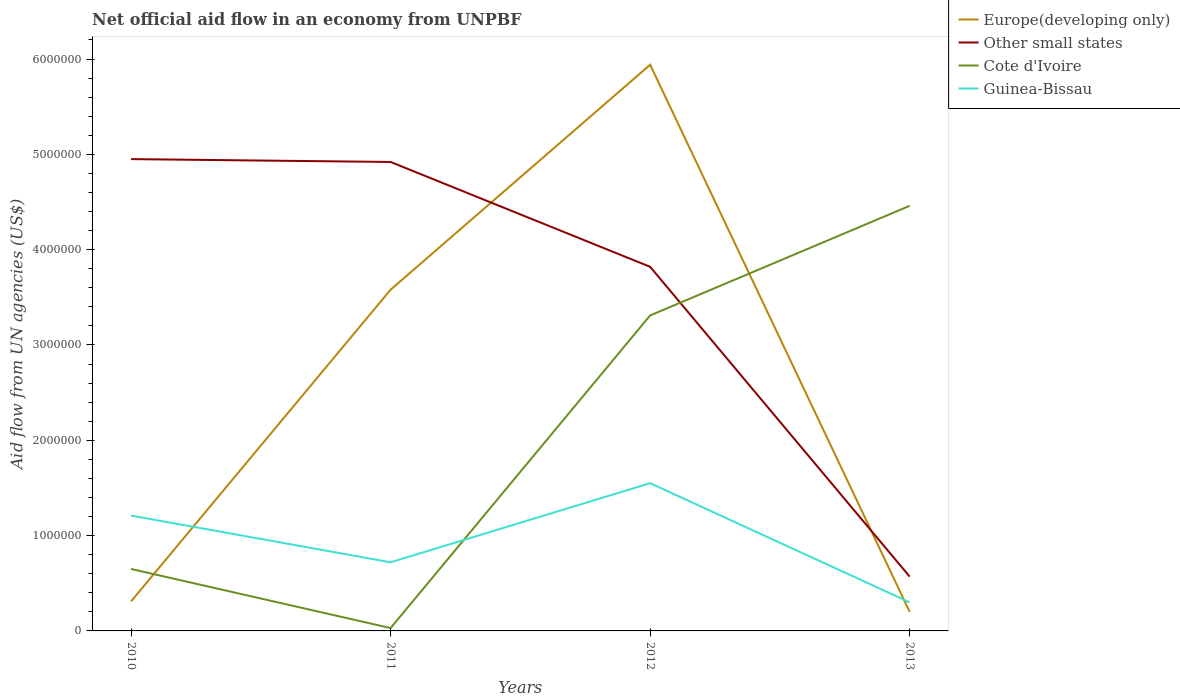How many different coloured lines are there?
Make the answer very short. 4. Is the number of lines equal to the number of legend labels?
Make the answer very short. Yes. Across all years, what is the maximum net official aid flow in Europe(developing only)?
Keep it short and to the point. 2.00e+05. In which year was the net official aid flow in Europe(developing only) maximum?
Keep it short and to the point. 2013. What is the total net official aid flow in Europe(developing only) in the graph?
Make the answer very short. -5.63e+06. What is the difference between the highest and the second highest net official aid flow in Cote d'Ivoire?
Give a very brief answer. 4.43e+06. How many years are there in the graph?
Your answer should be very brief. 4. Are the values on the major ticks of Y-axis written in scientific E-notation?
Your answer should be very brief. No. Where does the legend appear in the graph?
Your answer should be compact. Top right. What is the title of the graph?
Ensure brevity in your answer.  Net official aid flow in an economy from UNPBF. Does "Hungary" appear as one of the legend labels in the graph?
Give a very brief answer. No. What is the label or title of the Y-axis?
Offer a terse response. Aid flow from UN agencies (US$). What is the Aid flow from UN agencies (US$) of Europe(developing only) in 2010?
Your answer should be very brief. 3.10e+05. What is the Aid flow from UN agencies (US$) in Other small states in 2010?
Ensure brevity in your answer.  4.95e+06. What is the Aid flow from UN agencies (US$) of Cote d'Ivoire in 2010?
Make the answer very short. 6.50e+05. What is the Aid flow from UN agencies (US$) in Guinea-Bissau in 2010?
Offer a terse response. 1.21e+06. What is the Aid flow from UN agencies (US$) in Europe(developing only) in 2011?
Keep it short and to the point. 3.58e+06. What is the Aid flow from UN agencies (US$) of Other small states in 2011?
Provide a short and direct response. 4.92e+06. What is the Aid flow from UN agencies (US$) of Cote d'Ivoire in 2011?
Offer a very short reply. 3.00e+04. What is the Aid flow from UN agencies (US$) of Guinea-Bissau in 2011?
Keep it short and to the point. 7.20e+05. What is the Aid flow from UN agencies (US$) in Europe(developing only) in 2012?
Your response must be concise. 5.94e+06. What is the Aid flow from UN agencies (US$) of Other small states in 2012?
Ensure brevity in your answer.  3.82e+06. What is the Aid flow from UN agencies (US$) of Cote d'Ivoire in 2012?
Provide a short and direct response. 3.31e+06. What is the Aid flow from UN agencies (US$) of Guinea-Bissau in 2012?
Your answer should be compact. 1.55e+06. What is the Aid flow from UN agencies (US$) of Other small states in 2013?
Ensure brevity in your answer.  5.70e+05. What is the Aid flow from UN agencies (US$) of Cote d'Ivoire in 2013?
Your answer should be compact. 4.46e+06. Across all years, what is the maximum Aid flow from UN agencies (US$) in Europe(developing only)?
Offer a very short reply. 5.94e+06. Across all years, what is the maximum Aid flow from UN agencies (US$) of Other small states?
Offer a very short reply. 4.95e+06. Across all years, what is the maximum Aid flow from UN agencies (US$) of Cote d'Ivoire?
Ensure brevity in your answer.  4.46e+06. Across all years, what is the maximum Aid flow from UN agencies (US$) in Guinea-Bissau?
Ensure brevity in your answer.  1.55e+06. Across all years, what is the minimum Aid flow from UN agencies (US$) of Other small states?
Offer a terse response. 5.70e+05. Across all years, what is the minimum Aid flow from UN agencies (US$) in Cote d'Ivoire?
Provide a short and direct response. 3.00e+04. Across all years, what is the minimum Aid flow from UN agencies (US$) in Guinea-Bissau?
Provide a short and direct response. 3.00e+05. What is the total Aid flow from UN agencies (US$) in Europe(developing only) in the graph?
Offer a terse response. 1.00e+07. What is the total Aid flow from UN agencies (US$) in Other small states in the graph?
Give a very brief answer. 1.43e+07. What is the total Aid flow from UN agencies (US$) in Cote d'Ivoire in the graph?
Ensure brevity in your answer.  8.45e+06. What is the total Aid flow from UN agencies (US$) in Guinea-Bissau in the graph?
Offer a terse response. 3.78e+06. What is the difference between the Aid flow from UN agencies (US$) of Europe(developing only) in 2010 and that in 2011?
Give a very brief answer. -3.27e+06. What is the difference between the Aid flow from UN agencies (US$) of Other small states in 2010 and that in 2011?
Your answer should be compact. 3.00e+04. What is the difference between the Aid flow from UN agencies (US$) of Cote d'Ivoire in 2010 and that in 2011?
Offer a very short reply. 6.20e+05. What is the difference between the Aid flow from UN agencies (US$) of Europe(developing only) in 2010 and that in 2012?
Make the answer very short. -5.63e+06. What is the difference between the Aid flow from UN agencies (US$) of Other small states in 2010 and that in 2012?
Provide a succinct answer. 1.13e+06. What is the difference between the Aid flow from UN agencies (US$) of Cote d'Ivoire in 2010 and that in 2012?
Offer a terse response. -2.66e+06. What is the difference between the Aid flow from UN agencies (US$) of Europe(developing only) in 2010 and that in 2013?
Offer a terse response. 1.10e+05. What is the difference between the Aid flow from UN agencies (US$) of Other small states in 2010 and that in 2013?
Provide a short and direct response. 4.38e+06. What is the difference between the Aid flow from UN agencies (US$) of Cote d'Ivoire in 2010 and that in 2013?
Your response must be concise. -3.81e+06. What is the difference between the Aid flow from UN agencies (US$) of Guinea-Bissau in 2010 and that in 2013?
Give a very brief answer. 9.10e+05. What is the difference between the Aid flow from UN agencies (US$) in Europe(developing only) in 2011 and that in 2012?
Your answer should be compact. -2.36e+06. What is the difference between the Aid flow from UN agencies (US$) of Other small states in 2011 and that in 2012?
Offer a terse response. 1.10e+06. What is the difference between the Aid flow from UN agencies (US$) in Cote d'Ivoire in 2011 and that in 2012?
Offer a terse response. -3.28e+06. What is the difference between the Aid flow from UN agencies (US$) of Guinea-Bissau in 2011 and that in 2012?
Your answer should be very brief. -8.30e+05. What is the difference between the Aid flow from UN agencies (US$) in Europe(developing only) in 2011 and that in 2013?
Your answer should be very brief. 3.38e+06. What is the difference between the Aid flow from UN agencies (US$) of Other small states in 2011 and that in 2013?
Give a very brief answer. 4.35e+06. What is the difference between the Aid flow from UN agencies (US$) in Cote d'Ivoire in 2011 and that in 2013?
Make the answer very short. -4.43e+06. What is the difference between the Aid flow from UN agencies (US$) in Guinea-Bissau in 2011 and that in 2013?
Make the answer very short. 4.20e+05. What is the difference between the Aid flow from UN agencies (US$) of Europe(developing only) in 2012 and that in 2013?
Your answer should be compact. 5.74e+06. What is the difference between the Aid flow from UN agencies (US$) of Other small states in 2012 and that in 2013?
Your answer should be very brief. 3.25e+06. What is the difference between the Aid flow from UN agencies (US$) in Cote d'Ivoire in 2012 and that in 2013?
Your answer should be compact. -1.15e+06. What is the difference between the Aid flow from UN agencies (US$) in Guinea-Bissau in 2012 and that in 2013?
Provide a succinct answer. 1.25e+06. What is the difference between the Aid flow from UN agencies (US$) in Europe(developing only) in 2010 and the Aid flow from UN agencies (US$) in Other small states in 2011?
Ensure brevity in your answer.  -4.61e+06. What is the difference between the Aid flow from UN agencies (US$) in Europe(developing only) in 2010 and the Aid flow from UN agencies (US$) in Cote d'Ivoire in 2011?
Give a very brief answer. 2.80e+05. What is the difference between the Aid flow from UN agencies (US$) in Europe(developing only) in 2010 and the Aid flow from UN agencies (US$) in Guinea-Bissau in 2011?
Give a very brief answer. -4.10e+05. What is the difference between the Aid flow from UN agencies (US$) of Other small states in 2010 and the Aid flow from UN agencies (US$) of Cote d'Ivoire in 2011?
Offer a very short reply. 4.92e+06. What is the difference between the Aid flow from UN agencies (US$) of Other small states in 2010 and the Aid flow from UN agencies (US$) of Guinea-Bissau in 2011?
Your answer should be compact. 4.23e+06. What is the difference between the Aid flow from UN agencies (US$) in Cote d'Ivoire in 2010 and the Aid flow from UN agencies (US$) in Guinea-Bissau in 2011?
Make the answer very short. -7.00e+04. What is the difference between the Aid flow from UN agencies (US$) in Europe(developing only) in 2010 and the Aid flow from UN agencies (US$) in Other small states in 2012?
Your response must be concise. -3.51e+06. What is the difference between the Aid flow from UN agencies (US$) in Europe(developing only) in 2010 and the Aid flow from UN agencies (US$) in Guinea-Bissau in 2012?
Keep it short and to the point. -1.24e+06. What is the difference between the Aid flow from UN agencies (US$) in Other small states in 2010 and the Aid flow from UN agencies (US$) in Cote d'Ivoire in 2012?
Give a very brief answer. 1.64e+06. What is the difference between the Aid flow from UN agencies (US$) in Other small states in 2010 and the Aid flow from UN agencies (US$) in Guinea-Bissau in 2012?
Offer a very short reply. 3.40e+06. What is the difference between the Aid flow from UN agencies (US$) of Cote d'Ivoire in 2010 and the Aid flow from UN agencies (US$) of Guinea-Bissau in 2012?
Your answer should be very brief. -9.00e+05. What is the difference between the Aid flow from UN agencies (US$) of Europe(developing only) in 2010 and the Aid flow from UN agencies (US$) of Cote d'Ivoire in 2013?
Give a very brief answer. -4.15e+06. What is the difference between the Aid flow from UN agencies (US$) in Europe(developing only) in 2010 and the Aid flow from UN agencies (US$) in Guinea-Bissau in 2013?
Offer a terse response. 10000. What is the difference between the Aid flow from UN agencies (US$) in Other small states in 2010 and the Aid flow from UN agencies (US$) in Guinea-Bissau in 2013?
Your answer should be very brief. 4.65e+06. What is the difference between the Aid flow from UN agencies (US$) in Cote d'Ivoire in 2010 and the Aid flow from UN agencies (US$) in Guinea-Bissau in 2013?
Give a very brief answer. 3.50e+05. What is the difference between the Aid flow from UN agencies (US$) of Europe(developing only) in 2011 and the Aid flow from UN agencies (US$) of Other small states in 2012?
Give a very brief answer. -2.40e+05. What is the difference between the Aid flow from UN agencies (US$) in Europe(developing only) in 2011 and the Aid flow from UN agencies (US$) in Guinea-Bissau in 2012?
Keep it short and to the point. 2.03e+06. What is the difference between the Aid flow from UN agencies (US$) of Other small states in 2011 and the Aid flow from UN agencies (US$) of Cote d'Ivoire in 2012?
Offer a terse response. 1.61e+06. What is the difference between the Aid flow from UN agencies (US$) of Other small states in 2011 and the Aid flow from UN agencies (US$) of Guinea-Bissau in 2012?
Provide a succinct answer. 3.37e+06. What is the difference between the Aid flow from UN agencies (US$) in Cote d'Ivoire in 2011 and the Aid flow from UN agencies (US$) in Guinea-Bissau in 2012?
Your response must be concise. -1.52e+06. What is the difference between the Aid flow from UN agencies (US$) in Europe(developing only) in 2011 and the Aid flow from UN agencies (US$) in Other small states in 2013?
Your answer should be very brief. 3.01e+06. What is the difference between the Aid flow from UN agencies (US$) in Europe(developing only) in 2011 and the Aid flow from UN agencies (US$) in Cote d'Ivoire in 2013?
Keep it short and to the point. -8.80e+05. What is the difference between the Aid flow from UN agencies (US$) of Europe(developing only) in 2011 and the Aid flow from UN agencies (US$) of Guinea-Bissau in 2013?
Offer a terse response. 3.28e+06. What is the difference between the Aid flow from UN agencies (US$) of Other small states in 2011 and the Aid flow from UN agencies (US$) of Cote d'Ivoire in 2013?
Keep it short and to the point. 4.60e+05. What is the difference between the Aid flow from UN agencies (US$) of Other small states in 2011 and the Aid flow from UN agencies (US$) of Guinea-Bissau in 2013?
Keep it short and to the point. 4.62e+06. What is the difference between the Aid flow from UN agencies (US$) in Europe(developing only) in 2012 and the Aid flow from UN agencies (US$) in Other small states in 2013?
Provide a short and direct response. 5.37e+06. What is the difference between the Aid flow from UN agencies (US$) of Europe(developing only) in 2012 and the Aid flow from UN agencies (US$) of Cote d'Ivoire in 2013?
Keep it short and to the point. 1.48e+06. What is the difference between the Aid flow from UN agencies (US$) of Europe(developing only) in 2012 and the Aid flow from UN agencies (US$) of Guinea-Bissau in 2013?
Provide a succinct answer. 5.64e+06. What is the difference between the Aid flow from UN agencies (US$) of Other small states in 2012 and the Aid flow from UN agencies (US$) of Cote d'Ivoire in 2013?
Your response must be concise. -6.40e+05. What is the difference between the Aid flow from UN agencies (US$) of Other small states in 2012 and the Aid flow from UN agencies (US$) of Guinea-Bissau in 2013?
Offer a very short reply. 3.52e+06. What is the difference between the Aid flow from UN agencies (US$) of Cote d'Ivoire in 2012 and the Aid flow from UN agencies (US$) of Guinea-Bissau in 2013?
Your answer should be very brief. 3.01e+06. What is the average Aid flow from UN agencies (US$) of Europe(developing only) per year?
Give a very brief answer. 2.51e+06. What is the average Aid flow from UN agencies (US$) in Other small states per year?
Your answer should be very brief. 3.56e+06. What is the average Aid flow from UN agencies (US$) in Cote d'Ivoire per year?
Provide a succinct answer. 2.11e+06. What is the average Aid flow from UN agencies (US$) in Guinea-Bissau per year?
Give a very brief answer. 9.45e+05. In the year 2010, what is the difference between the Aid flow from UN agencies (US$) of Europe(developing only) and Aid flow from UN agencies (US$) of Other small states?
Ensure brevity in your answer.  -4.64e+06. In the year 2010, what is the difference between the Aid flow from UN agencies (US$) of Europe(developing only) and Aid flow from UN agencies (US$) of Guinea-Bissau?
Provide a short and direct response. -9.00e+05. In the year 2010, what is the difference between the Aid flow from UN agencies (US$) in Other small states and Aid flow from UN agencies (US$) in Cote d'Ivoire?
Provide a short and direct response. 4.30e+06. In the year 2010, what is the difference between the Aid flow from UN agencies (US$) of Other small states and Aid flow from UN agencies (US$) of Guinea-Bissau?
Your response must be concise. 3.74e+06. In the year 2010, what is the difference between the Aid flow from UN agencies (US$) of Cote d'Ivoire and Aid flow from UN agencies (US$) of Guinea-Bissau?
Offer a very short reply. -5.60e+05. In the year 2011, what is the difference between the Aid flow from UN agencies (US$) in Europe(developing only) and Aid flow from UN agencies (US$) in Other small states?
Your response must be concise. -1.34e+06. In the year 2011, what is the difference between the Aid flow from UN agencies (US$) of Europe(developing only) and Aid flow from UN agencies (US$) of Cote d'Ivoire?
Your response must be concise. 3.55e+06. In the year 2011, what is the difference between the Aid flow from UN agencies (US$) of Europe(developing only) and Aid flow from UN agencies (US$) of Guinea-Bissau?
Your answer should be compact. 2.86e+06. In the year 2011, what is the difference between the Aid flow from UN agencies (US$) in Other small states and Aid flow from UN agencies (US$) in Cote d'Ivoire?
Your response must be concise. 4.89e+06. In the year 2011, what is the difference between the Aid flow from UN agencies (US$) of Other small states and Aid flow from UN agencies (US$) of Guinea-Bissau?
Offer a terse response. 4.20e+06. In the year 2011, what is the difference between the Aid flow from UN agencies (US$) in Cote d'Ivoire and Aid flow from UN agencies (US$) in Guinea-Bissau?
Your answer should be very brief. -6.90e+05. In the year 2012, what is the difference between the Aid flow from UN agencies (US$) of Europe(developing only) and Aid flow from UN agencies (US$) of Other small states?
Offer a very short reply. 2.12e+06. In the year 2012, what is the difference between the Aid flow from UN agencies (US$) in Europe(developing only) and Aid flow from UN agencies (US$) in Cote d'Ivoire?
Make the answer very short. 2.63e+06. In the year 2012, what is the difference between the Aid flow from UN agencies (US$) in Europe(developing only) and Aid flow from UN agencies (US$) in Guinea-Bissau?
Your response must be concise. 4.39e+06. In the year 2012, what is the difference between the Aid flow from UN agencies (US$) of Other small states and Aid flow from UN agencies (US$) of Cote d'Ivoire?
Ensure brevity in your answer.  5.10e+05. In the year 2012, what is the difference between the Aid flow from UN agencies (US$) of Other small states and Aid flow from UN agencies (US$) of Guinea-Bissau?
Give a very brief answer. 2.27e+06. In the year 2012, what is the difference between the Aid flow from UN agencies (US$) of Cote d'Ivoire and Aid flow from UN agencies (US$) of Guinea-Bissau?
Provide a succinct answer. 1.76e+06. In the year 2013, what is the difference between the Aid flow from UN agencies (US$) in Europe(developing only) and Aid flow from UN agencies (US$) in Other small states?
Offer a very short reply. -3.70e+05. In the year 2013, what is the difference between the Aid flow from UN agencies (US$) of Europe(developing only) and Aid flow from UN agencies (US$) of Cote d'Ivoire?
Offer a very short reply. -4.26e+06. In the year 2013, what is the difference between the Aid flow from UN agencies (US$) of Europe(developing only) and Aid flow from UN agencies (US$) of Guinea-Bissau?
Provide a short and direct response. -1.00e+05. In the year 2013, what is the difference between the Aid flow from UN agencies (US$) of Other small states and Aid flow from UN agencies (US$) of Cote d'Ivoire?
Ensure brevity in your answer.  -3.89e+06. In the year 2013, what is the difference between the Aid flow from UN agencies (US$) in Cote d'Ivoire and Aid flow from UN agencies (US$) in Guinea-Bissau?
Your response must be concise. 4.16e+06. What is the ratio of the Aid flow from UN agencies (US$) of Europe(developing only) in 2010 to that in 2011?
Ensure brevity in your answer.  0.09. What is the ratio of the Aid flow from UN agencies (US$) of Other small states in 2010 to that in 2011?
Offer a terse response. 1.01. What is the ratio of the Aid flow from UN agencies (US$) of Cote d'Ivoire in 2010 to that in 2011?
Keep it short and to the point. 21.67. What is the ratio of the Aid flow from UN agencies (US$) in Guinea-Bissau in 2010 to that in 2011?
Give a very brief answer. 1.68. What is the ratio of the Aid flow from UN agencies (US$) of Europe(developing only) in 2010 to that in 2012?
Offer a terse response. 0.05. What is the ratio of the Aid flow from UN agencies (US$) of Other small states in 2010 to that in 2012?
Ensure brevity in your answer.  1.3. What is the ratio of the Aid flow from UN agencies (US$) in Cote d'Ivoire in 2010 to that in 2012?
Your response must be concise. 0.2. What is the ratio of the Aid flow from UN agencies (US$) of Guinea-Bissau in 2010 to that in 2012?
Offer a very short reply. 0.78. What is the ratio of the Aid flow from UN agencies (US$) of Europe(developing only) in 2010 to that in 2013?
Make the answer very short. 1.55. What is the ratio of the Aid flow from UN agencies (US$) in Other small states in 2010 to that in 2013?
Make the answer very short. 8.68. What is the ratio of the Aid flow from UN agencies (US$) of Cote d'Ivoire in 2010 to that in 2013?
Keep it short and to the point. 0.15. What is the ratio of the Aid flow from UN agencies (US$) in Guinea-Bissau in 2010 to that in 2013?
Offer a terse response. 4.03. What is the ratio of the Aid flow from UN agencies (US$) of Europe(developing only) in 2011 to that in 2012?
Offer a very short reply. 0.6. What is the ratio of the Aid flow from UN agencies (US$) in Other small states in 2011 to that in 2012?
Offer a terse response. 1.29. What is the ratio of the Aid flow from UN agencies (US$) of Cote d'Ivoire in 2011 to that in 2012?
Offer a terse response. 0.01. What is the ratio of the Aid flow from UN agencies (US$) in Guinea-Bissau in 2011 to that in 2012?
Offer a very short reply. 0.46. What is the ratio of the Aid flow from UN agencies (US$) of Other small states in 2011 to that in 2013?
Keep it short and to the point. 8.63. What is the ratio of the Aid flow from UN agencies (US$) in Cote d'Ivoire in 2011 to that in 2013?
Provide a succinct answer. 0.01. What is the ratio of the Aid flow from UN agencies (US$) in Guinea-Bissau in 2011 to that in 2013?
Ensure brevity in your answer.  2.4. What is the ratio of the Aid flow from UN agencies (US$) in Europe(developing only) in 2012 to that in 2013?
Make the answer very short. 29.7. What is the ratio of the Aid flow from UN agencies (US$) of Other small states in 2012 to that in 2013?
Keep it short and to the point. 6.7. What is the ratio of the Aid flow from UN agencies (US$) in Cote d'Ivoire in 2012 to that in 2013?
Provide a succinct answer. 0.74. What is the ratio of the Aid flow from UN agencies (US$) of Guinea-Bissau in 2012 to that in 2013?
Your answer should be very brief. 5.17. What is the difference between the highest and the second highest Aid flow from UN agencies (US$) of Europe(developing only)?
Provide a short and direct response. 2.36e+06. What is the difference between the highest and the second highest Aid flow from UN agencies (US$) in Cote d'Ivoire?
Give a very brief answer. 1.15e+06. What is the difference between the highest and the second highest Aid flow from UN agencies (US$) in Guinea-Bissau?
Your answer should be compact. 3.40e+05. What is the difference between the highest and the lowest Aid flow from UN agencies (US$) of Europe(developing only)?
Offer a very short reply. 5.74e+06. What is the difference between the highest and the lowest Aid flow from UN agencies (US$) in Other small states?
Ensure brevity in your answer.  4.38e+06. What is the difference between the highest and the lowest Aid flow from UN agencies (US$) in Cote d'Ivoire?
Your answer should be compact. 4.43e+06. What is the difference between the highest and the lowest Aid flow from UN agencies (US$) of Guinea-Bissau?
Ensure brevity in your answer.  1.25e+06. 